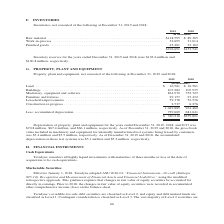According to Teradyne's financial document, What was the inventory reserves in 2019? According to the financial document, $103.6 million. The relevant text states: "or the years ended December 31, 2019 and 2018 were $103.6 million and $100.8 million, respectively...." Also, In which years was net inventories calculated? The document shows two values: 2019 and 2018. From the document: "2019 2018 2019 2018..." Also, What were the components included in net inventories in the table? The document contains multiple relevant values: Raw material, Work-in-process, Finished goods. From the document: "(in thousands) Raw material . $118,595 $ 89,365 Work-in-process . 32,695 31,014 Finished goods . 45,401 33,162 $118,595 $ 89,365 Work-in-process . 32,..." Additionally, In which year was Work-in-process larger? According to the financial document, 2019. The relevant text states: "2019 2018..." Also, can you calculate: What was the change in Finished goods from 2018 to 2019? Based on the calculation: 45,401-33,162, the result is 12239 (in thousands). This is based on the information: "Work-in-process . 32,695 31,014 Finished goods . 45,401 33,162 n-process . 32,695 31,014 Finished goods . 45,401 33,162..." The key data points involved are: 33,162, 45,401. Also, can you calculate: What was the percentage change in Finished goods from 2018 to 2019? To answer this question, I need to perform calculations using the financial data. The calculation is: (45,401-33,162)/33,162, which equals 36.91 (percentage). This is based on the information: "Work-in-process . 32,695 31,014 Finished goods . 45,401 33,162 n-process . 32,695 31,014 Finished goods . 45,401 33,162..." The key data points involved are: 33,162, 45,401. 